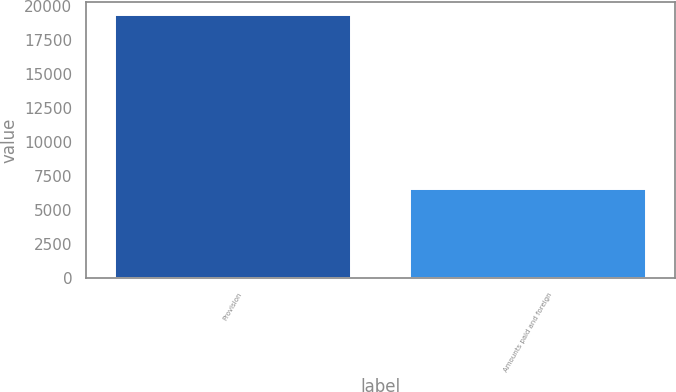<chart> <loc_0><loc_0><loc_500><loc_500><bar_chart><fcel>Provision<fcel>Amounts paid and foreign<nl><fcel>19318<fcel>6568<nl></chart> 